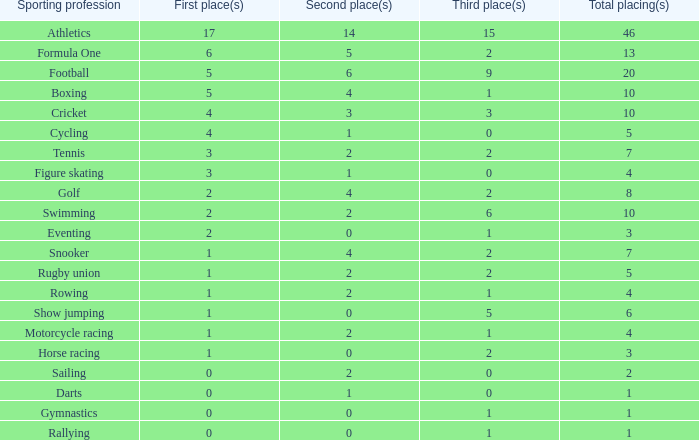What is the total number of 3rd place entries that have exactly 8 total placings? 1.0. 